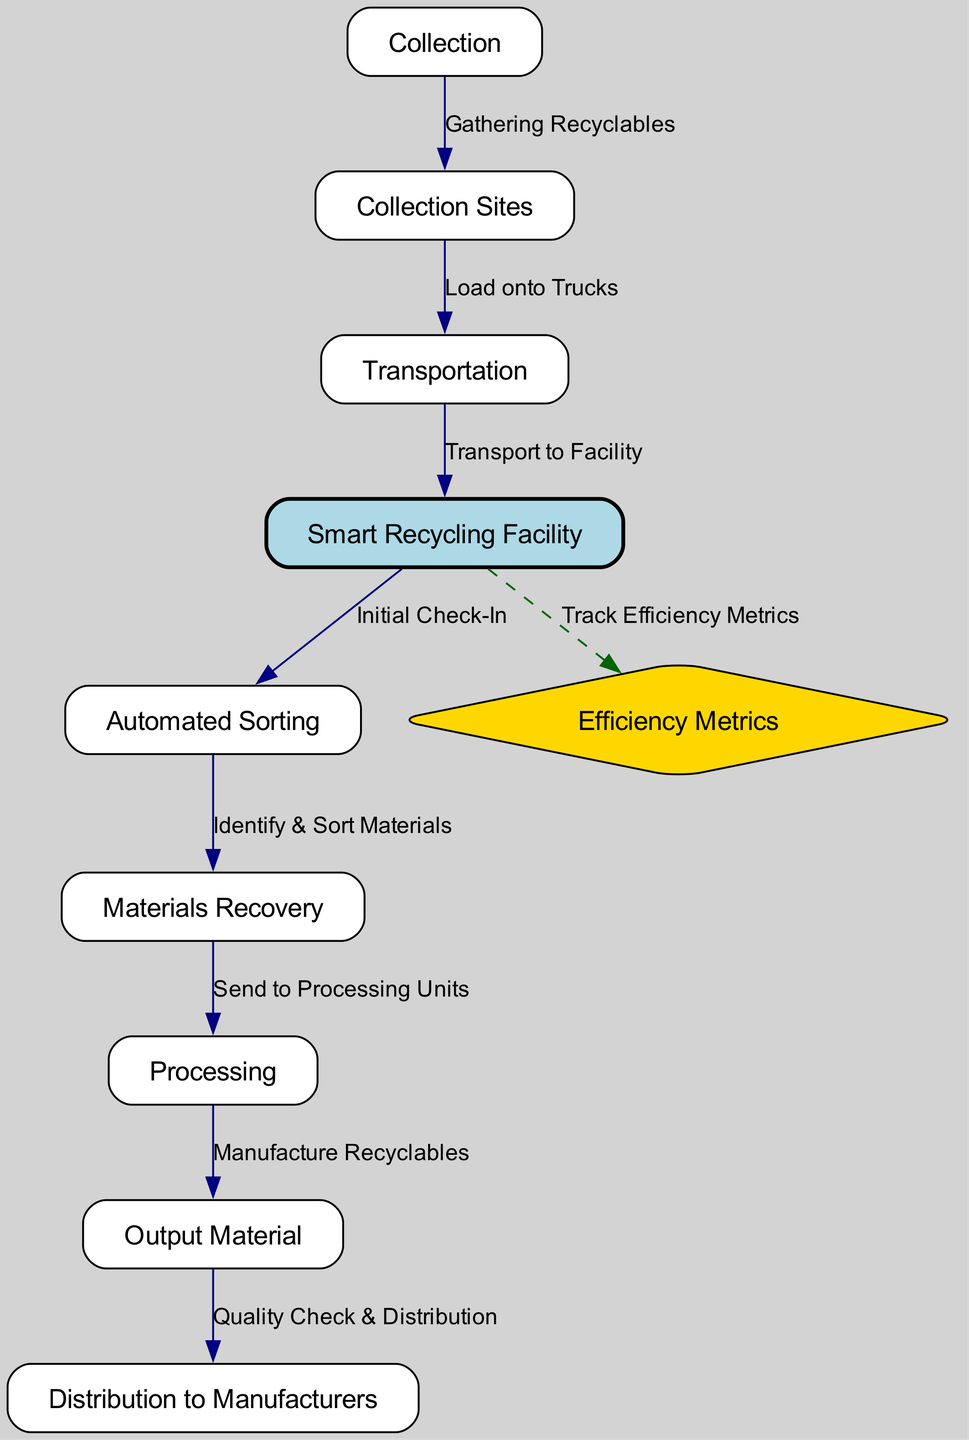What are the first two stages in the recycling lifecycle? The diagram shows that the first stage is 'Collection', followed by 'Collection Sites'. These are the initial steps where recyclables are gathered before transportation.
Answer: Collection, Collection Sites How many stages are there from sorting to distribution? The stages following 'Sorting' include 'Materials Recovery', 'Processing', 'Output Material', and 'Distribution'. Thus, there are four stages in total between sorting and distribution.
Answer: Four What type of node is 'Efficiency Metrics'? In the diagram, 'Efficiency Metrics' is represented as a diamond shape, indicating it has a specific designation or importance in the lifecycle process compared to other rectangular nodes.
Answer: Diamond What label connects 'Transport to Facility' and 'Transportation'? The edge between 'Transportation' and 'Smart Recycling Facility' is labeled 'Transport to Facility', indicating the transportation process leads directly to the facility.
Answer: Transport to Facility What is the last step in the recycling process before distribution? The final step before the output material is sent for distribution is 'Quality Check & Distribution', as indicated by the arrow leading directly to 'Distribution to Manufacturers'.
Answer: Quality Check & Distribution How does the smart recycling facility monitor its performance? The diagram indicates that the smart facility tracks its performance through 'Efficiency Metrics', which measures various metrics to ensure operational effectiveness.
Answer: Track Efficiency Metrics How many edges connect the stages of processing? 'Processing' connects to 'Output Material' and has one direct edge leading to it. Thus, there is one edge that connects 'Processing' to a subsequent stage.
Answer: One Which stage involves identifying and sorting materials? The 'Automated Sorting' stage is specifically designated for identifying and sorting the materials retrieved during the recycling process.
Answer: Automated Sorting What process occurs after materials recovery? After 'Materials Recovery', the next step is 'Processing', indicating that recovered materials are sent to processing units for further handling.
Answer: Processing 